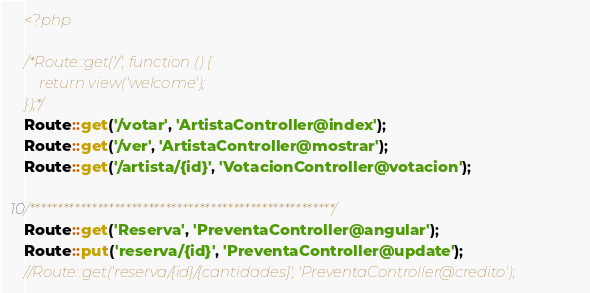Convert code to text. <code><loc_0><loc_0><loc_500><loc_500><_PHP_><?php

/*Route::get('/', function () {
    return view('welcome');
});*/
Route::get('/votar', 'ArtistaController@index');
Route::get('/ver', 'ArtistaController@mostrar');
Route::get('/artista/{id}', 'VotacionController@votacion');

/******************************************************/
Route::get('Reserva', 'PreventaController@angular');
Route::put('reserva/{id}', 'PreventaController@update');
//Route::get('reserva/{id}/{cantidades}', 'PreventaController@credito');</code> 